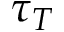Convert formula to latex. <formula><loc_0><loc_0><loc_500><loc_500>\tau _ { T }</formula> 